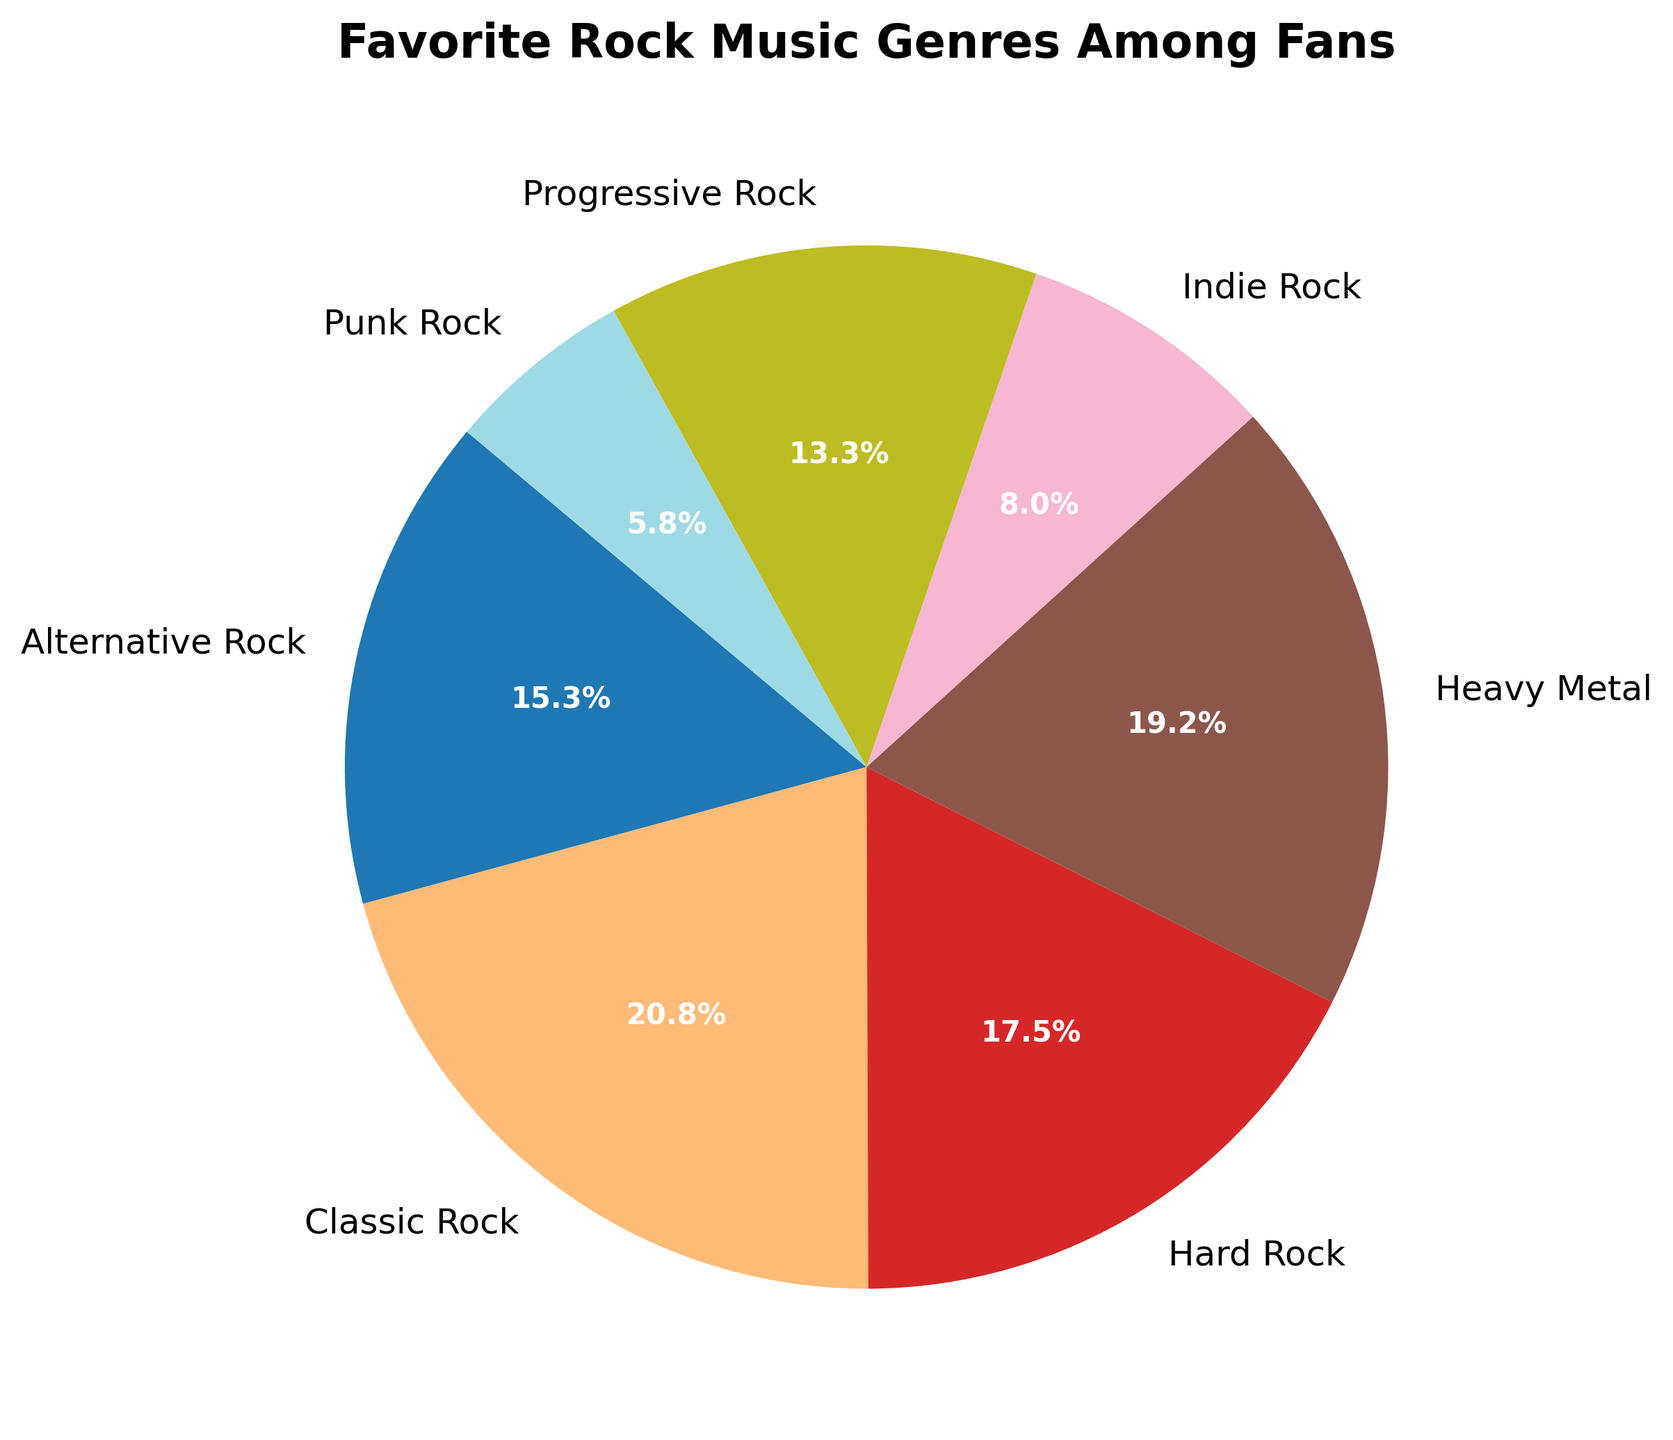What percentage of fans prefer Classic Rock across all age groups? Sum up the percentages of Classic Rock fans across all age groups: 15 (13-18) + 12 (19-25) + 18 (26-35) + 20 (36-45) + 25 (46-60) + 35 (60+). The total is 125%.
Answer: 125% Which rock genre is the least popular among fans aged 19-25? Identify the genre with the smallest percentage in the 19-25 age group: Classic Rock (12), Hard Rock (22), Alternative Rock (30), Punk Rock (8), Progressive Rock (7), Heavy Metal (15), Indie Rock (6). Indie Rock has the smallest percentage.
Answer: Indie Rock Is Heavy Metal more popular among fans aged 36-45 or 46-60? Compare the percentages for Heavy Metal in the two age groups: 36-45 (25%) and 46-60 (22%). Heavy Metal is more popular among fans aged 36-45.
Answer: 36-45 What is the visual difference in the pie chart between Classic Rock and Alternative Rock? Identify the visual elements: Classic Rock slices are larger with different colors and more segments, indicating a higher percentage compared to Alternative Rock, which has smaller and fewer segments.
Answer: Classic Rock slices are larger and more segmented What's the average percentage of fans who prefer Progressive Rock across all age groups? Calculate the average by summing the percentages and dividing by the number of age groups: (5+7+15+15+20+18)/6 = 80/6 = 13.33%.
Answer: 13.33% How much larger is the percentage of fans who prefer Classic Rock over those who prefer Progressive Rock among fans aged 46-60? Calculate the difference: Classic Rock (25%) - Progressive Rock (20%) = 5%.
Answer: 5% Which genre has the highest overall percentage, and what is that percentage? Identify the genre with the largest slice in the pie chart by comparing overall percentages: Classic Rock (125), Hard Rock (105), Alternative Rock (92), Punk Rock (35), Progressive Rock (80), Heavy Metal (115), Indie Rock (48). Classic Rock has the highest overall percentage.
Answer: Classic Rock, 125% What is the sum of the percentages of fans aged 60+ who prefer Hard Rock and Heavy Metal? Add the percentages: Hard Rock (10%) + Heavy Metal (20%) = 30%.
Answer: 30% 